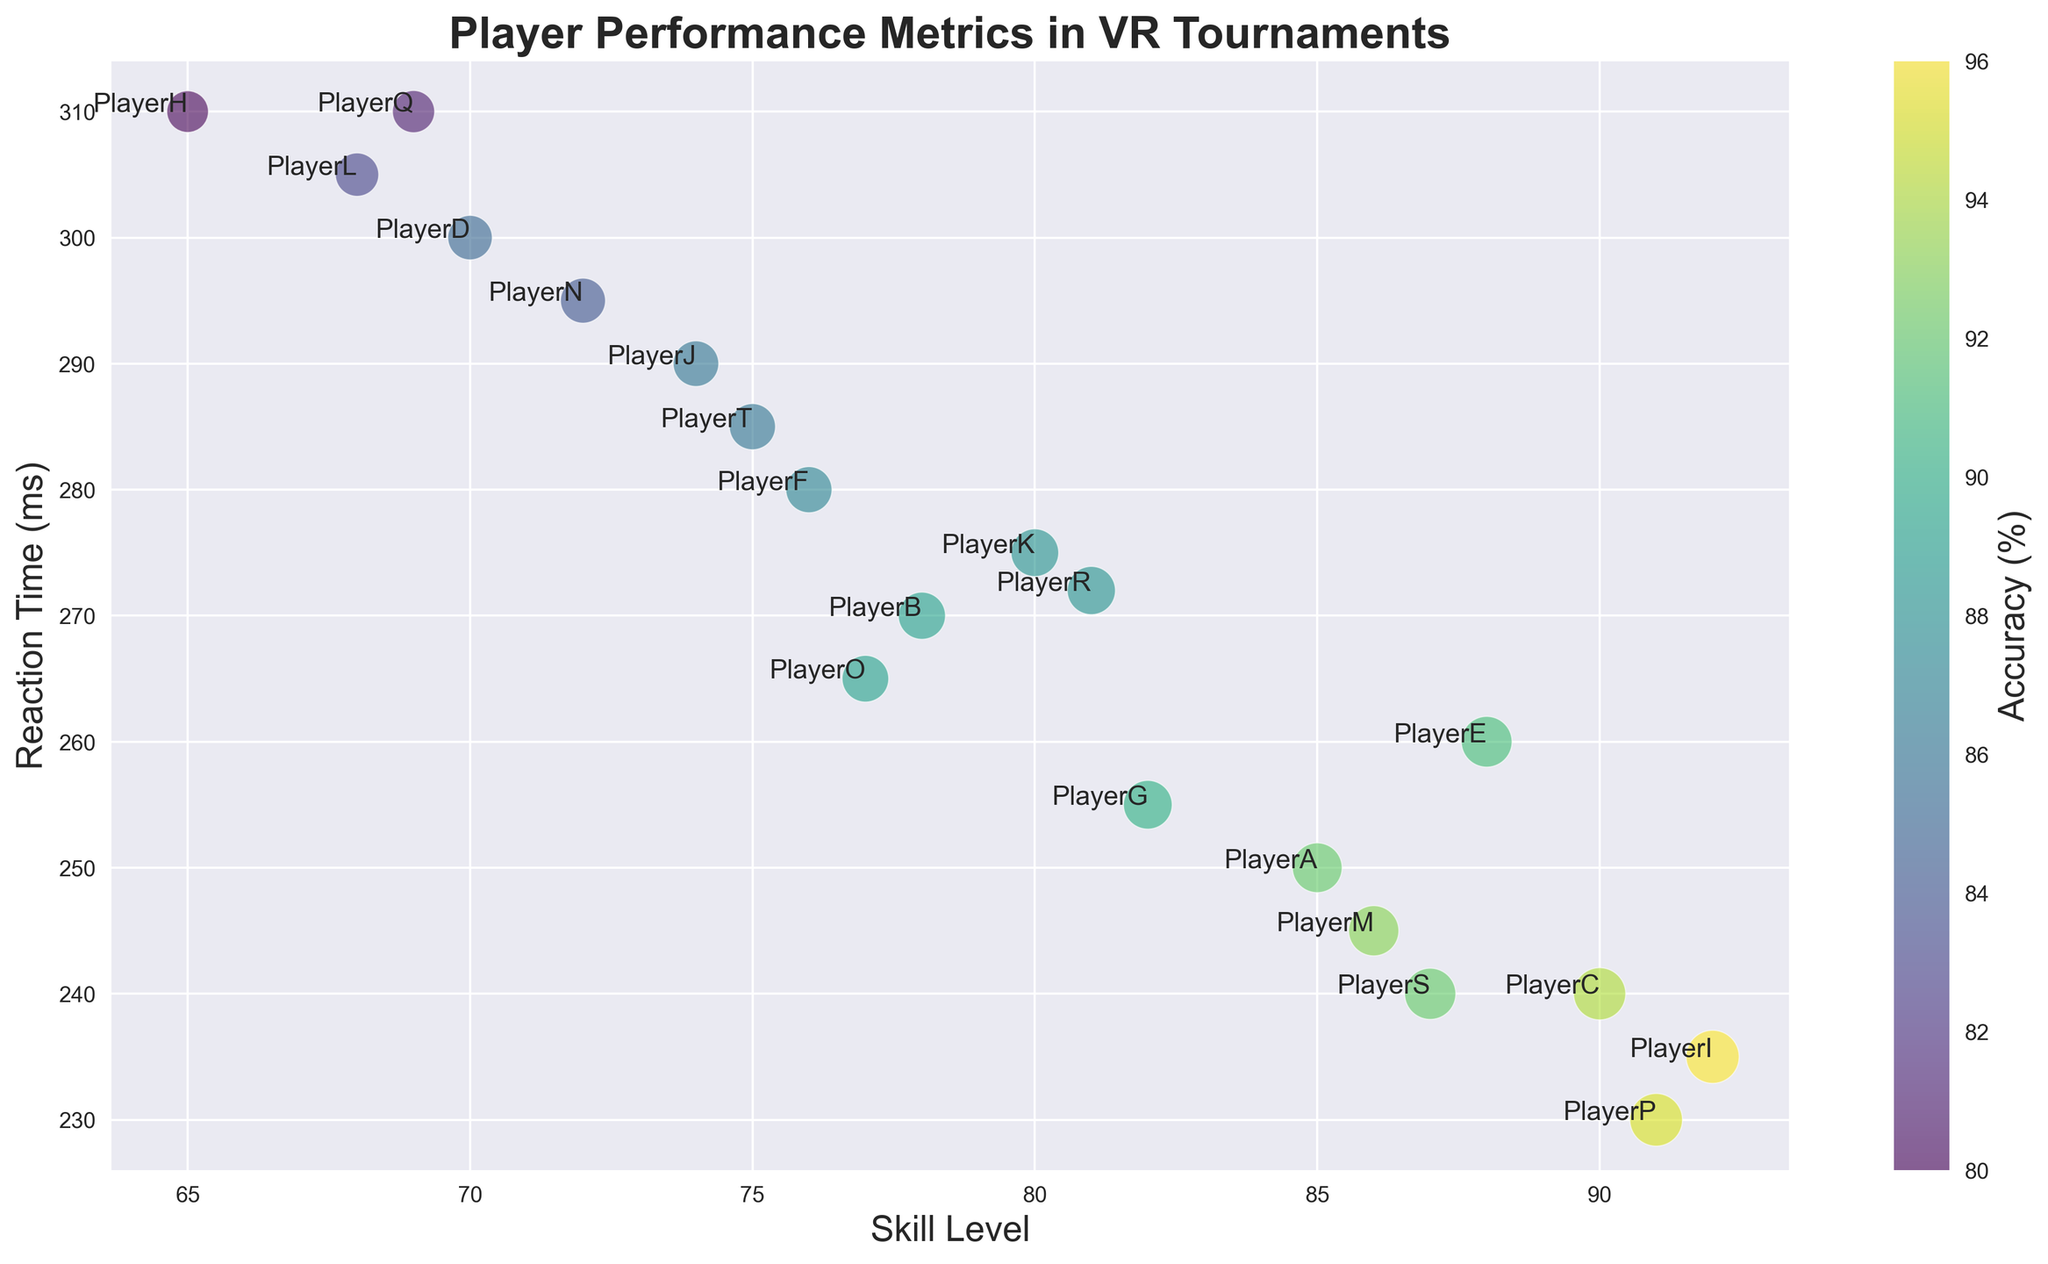What's the skill level of the player with the lowest reaction time? First, identify the player with the lowest reaction time, which is 'PlayerP' at 230 ms. Then, find the corresponding skill level for 'PlayerP', which is 91.
Answer: 91 Which player has the highest accuracy and what is their reaction time? Find the player with the highest accuracy, which is 96% for 'PlayerI'. Then, note down the reaction time for 'PlayerI', which is 235 ms.
Answer: PlayerI, 235 ms Among players with an accuracy above 90%, who has the highest skill level? Look at players with an accuracy > 90%. These players are 'PlayerA', 'PlayerC', 'PlayerE', 'PlayerI', 'PlayerM', 'PlayerP', and 'PlayerS'. Among them, 'PlayerI' has the highest skill level of 92.
Answer: PlayerI Are there any players with both a skill level below 70 and reaction time above 300 ms? Scan through the data points to check if any players meet both criteria. 'PlayerH' has a skill level of 65 and a reaction time of 310 ms, which satisfies both conditions.
Answer: Yes, PlayerH What is the average accuracy of players with a reaction time below 250 ms? Identify players with a reaction time below 250 ms: 'PlayerI', 'PlayerC', 'PlayerS', and 'PlayerP'. Their accuracies are 96%, 94%, 92%, and 95%, respectively. Calculate the average: (96 + 94 + 92 + 95) / 4 = 94.25.
Answer: 94.25% Who has the largest bubble size and what are their corresponding skill level and accuracy? Identify the player with the largest bubble size, which is 'PlayerI' with a bubble size of 57. The corresponding skill level and accuracy for 'PlayerI' are 92 and 96%, respectively.
Answer: PlayerI, 92, 96% Compare the reaction times of 'PlayerG' and 'PlayerS'. Which one is faster? Extract the reaction times for 'PlayerG' and 'PlayerS'. 'PlayerG' has a reaction time of 255 ms and 'PlayerS' has a reaction time of 240 ms. Since 240 ms is less than 255 ms, 'PlayerS' is faster.
Answer: PlayerS What is the combined bubble size of 'PlayerF' and 'PlayerN'? Find the bubble sizes of 'PlayerF' and 'PlayerN', which are 43 and 41, respectively. Add them up: 43 + 41 = 84.
Answer: 84 How many players have both a skill level above 80 and accuracy above 90%? Count the players who meet both criteria: 'PlayerA', 'PlayerC', 'PlayerE', 'PlayerI', 'PlayerM', 'PlayerS', and 'PlayerP'. There are 7 such players.
Answer: 7 Which player has the lowest accuracy and what is their skill level? Identify the player with the lowest accuracy, which is 'PlayerH' at 80%. The corresponding skill level for 'PlayerH' is 65.
Answer: PlayerH, 65 